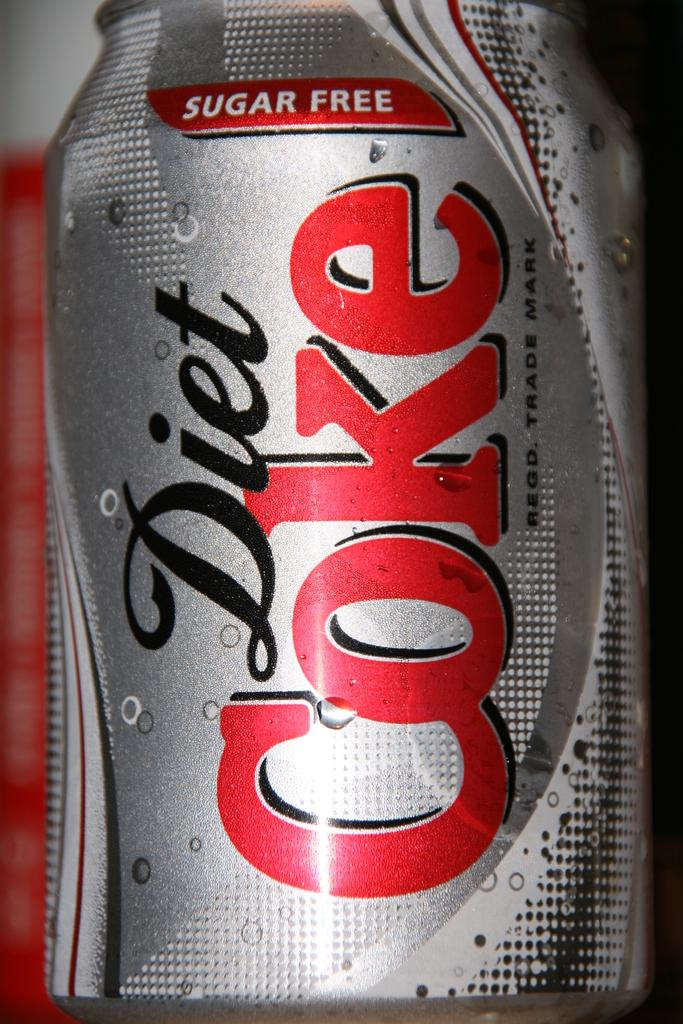Provide a one-sentence caption for the provided image. A silver can of Diet Coke claims to be sugar free. 